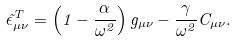Convert formula to latex. <formula><loc_0><loc_0><loc_500><loc_500>\tilde { \epsilon } _ { \mu \nu } ^ { T } = \left ( 1 - \frac { \alpha } { \omega ^ { 2 } } \right ) g _ { \mu \nu } - \frac { \gamma } { \omega ^ { 2 } } C _ { \mu \nu } .</formula> 